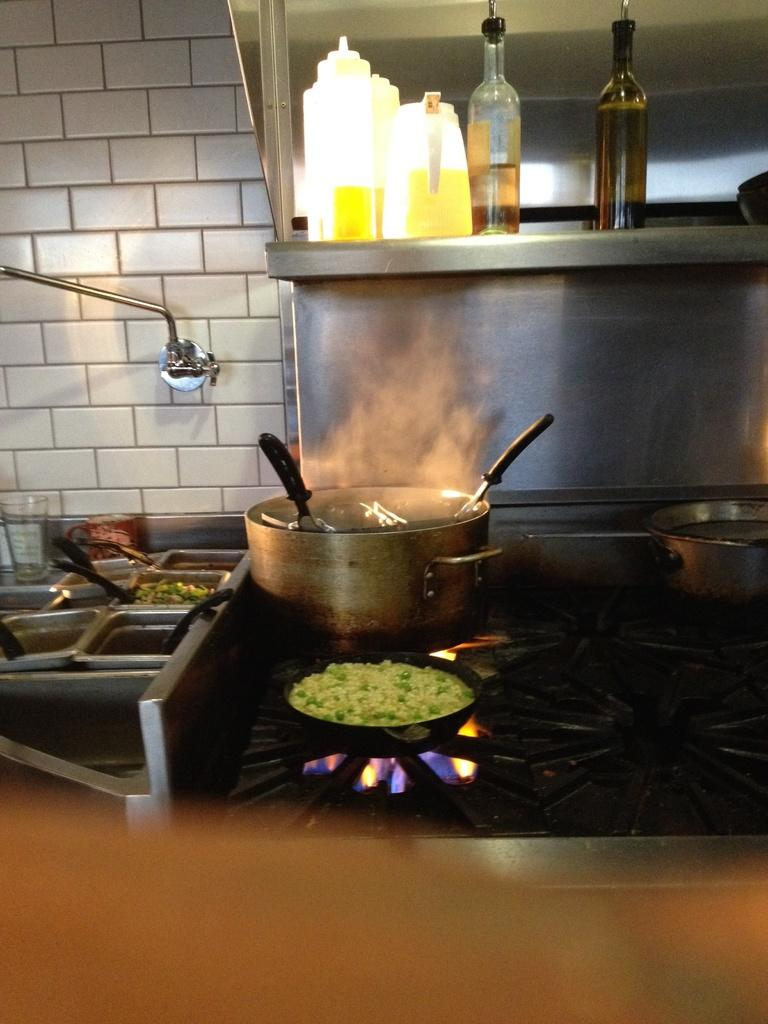What is on the stove in the image? There is a container and a pan on the stove in the image. What else can be seen on the stove besides the pan? There is a container on the stove. Can you describe any other objects visible in the image? Yes, there are containers visible in the image. What is located above the steel table in the image? There are bottles above the steel table in the image. What type of porter is carrying the containers in the image? There is no porter present in the image; it only shows containers on the stove and bottles above a steel table. What type of machine is used to prepare the food in the image? There is no machine visible in the image; it only shows a stove with a container and a pan on it. 